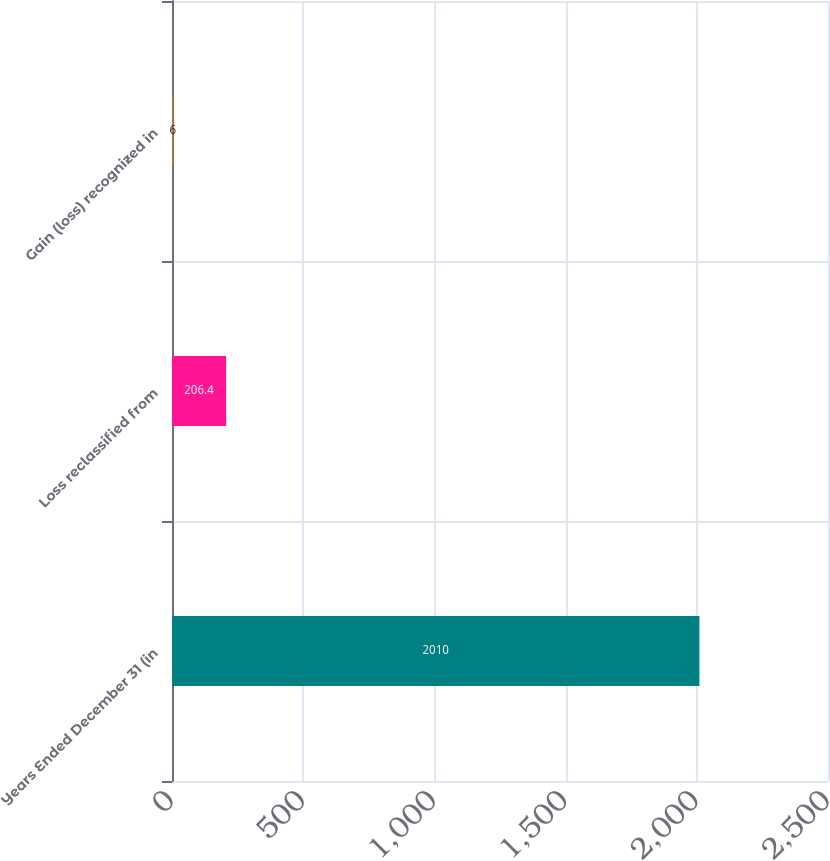Convert chart to OTSL. <chart><loc_0><loc_0><loc_500><loc_500><bar_chart><fcel>Years Ended December 31 (in<fcel>Loss reclassified from<fcel>Gain (loss) recognized in<nl><fcel>2010<fcel>206.4<fcel>6<nl></chart> 